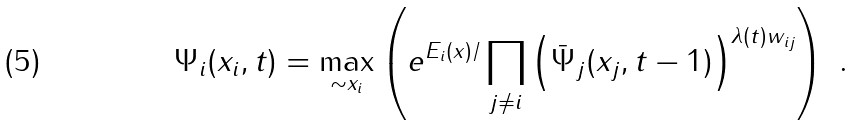<formula> <loc_0><loc_0><loc_500><loc_500>\Psi _ { i } ( x _ { i } , t ) = \max _ { \sim x _ { i } } \left ( e ^ { E _ { i } ( x ) / } \prod _ { j \not = i } \left ( { \bar { \Psi } } _ { j } ( x _ { j } , t - 1 ) \right ) ^ { \lambda ( t ) w _ { i j } } \right ) \ .</formula> 